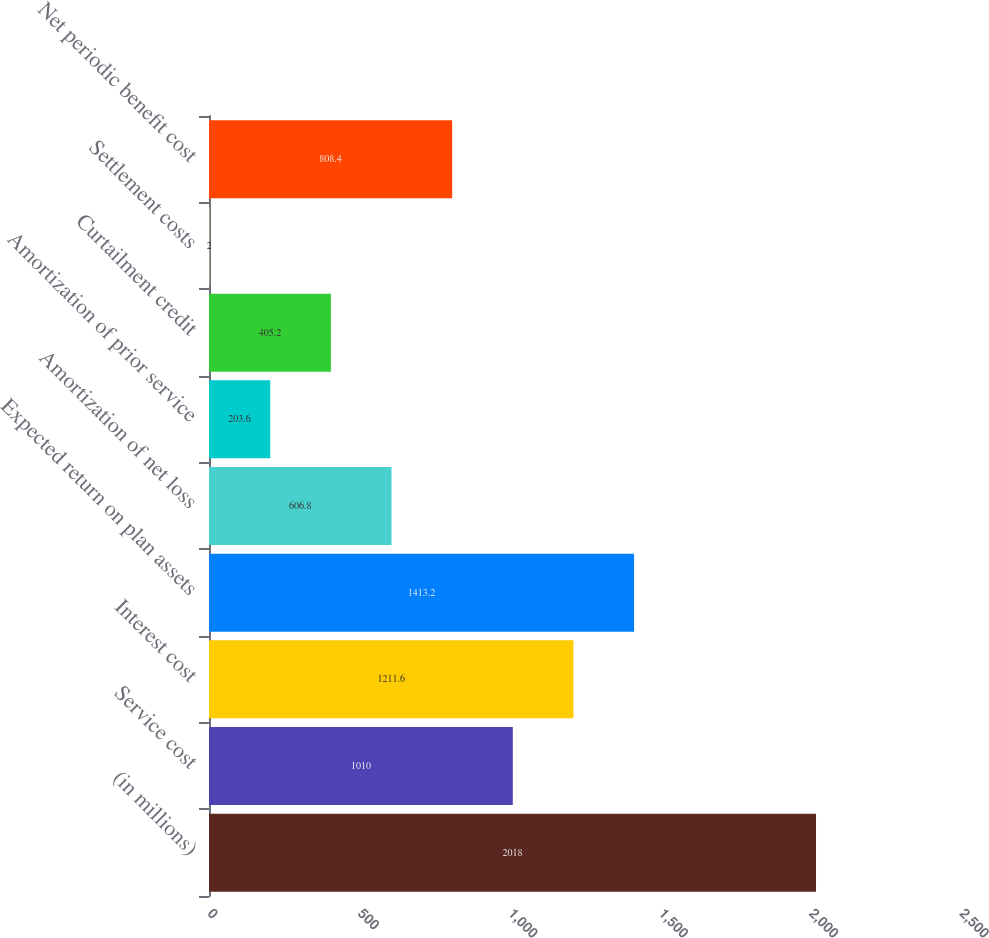Convert chart. <chart><loc_0><loc_0><loc_500><loc_500><bar_chart><fcel>(in millions)<fcel>Service cost<fcel>Interest cost<fcel>Expected return on plan assets<fcel>Amortization of net loss<fcel>Amortization of prior service<fcel>Curtailment credit<fcel>Settlement costs<fcel>Net periodic benefit cost<nl><fcel>2018<fcel>1010<fcel>1211.6<fcel>1413.2<fcel>606.8<fcel>203.6<fcel>405.2<fcel>2<fcel>808.4<nl></chart> 